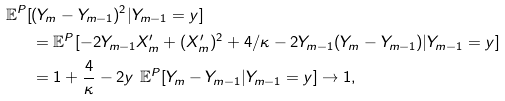Convert formula to latex. <formula><loc_0><loc_0><loc_500><loc_500>\mathbb { E } ^ { P } [ & ( Y _ { m } - Y _ { m - 1 } ) ^ { 2 } | Y _ { m - 1 } = y ] \\ & = \mathbb { E } ^ { P } [ - 2 Y _ { m - 1 } X _ { m } ^ { \prime } + ( X _ { m } ^ { \prime } ) ^ { 2 } + 4 / \kappa - 2 Y _ { m - 1 } ( Y _ { m } - Y _ { m - 1 } ) | Y _ { m - 1 } = y ] \\ & = 1 + \frac { 4 } { \kappa } - 2 y \ \mathbb { E } ^ { P } [ Y _ { m } - Y _ { m - 1 } | Y _ { m - 1 } = y ] \to 1 ,</formula> 